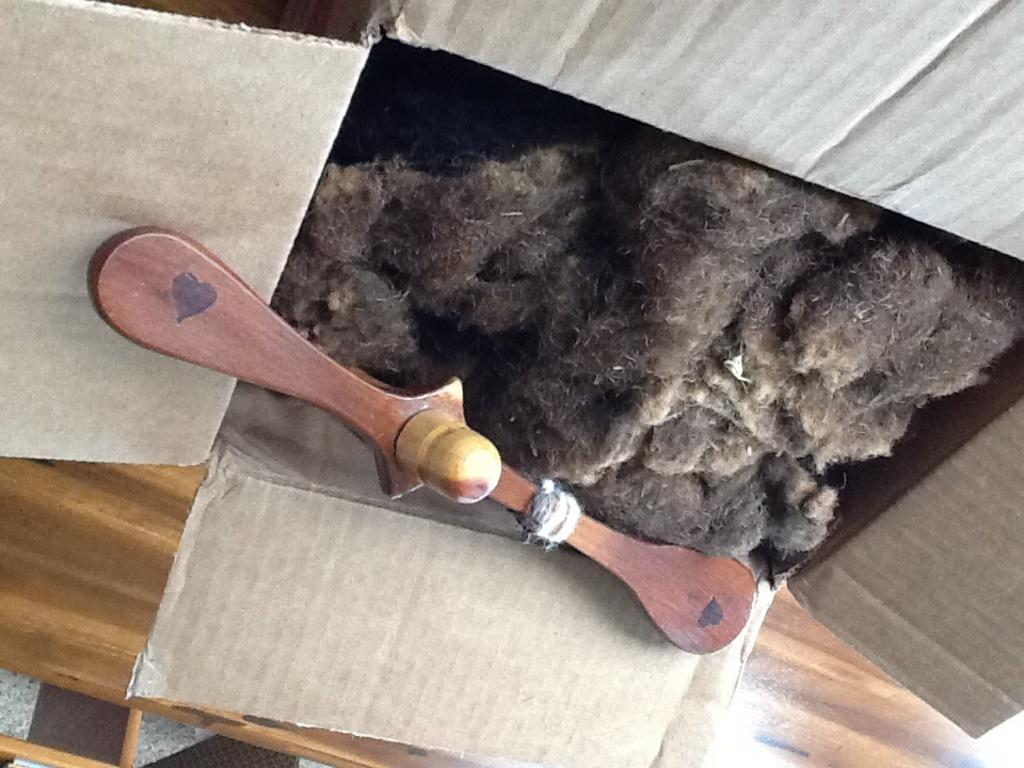What object is present in the image? There is a box in the image. What is the color of the box? The box is dark brown in color. What is inside the box? There is a cotton material inside the box. What is the color of the cotton material? The cotton material is dark brown in color. What other object is present in the box? There is a wooden handle in the box. What is the box placed on? The box is placed on a wooden plank. What type of breakfast is being prepared in the box? There is no indication of breakfast or any food preparation in the image; it features a box with a cotton material and a wooden handle. Who is the aunt mentioned in the image? There is no mention of an aunt or any person in the image; it only features a box and its contents. 